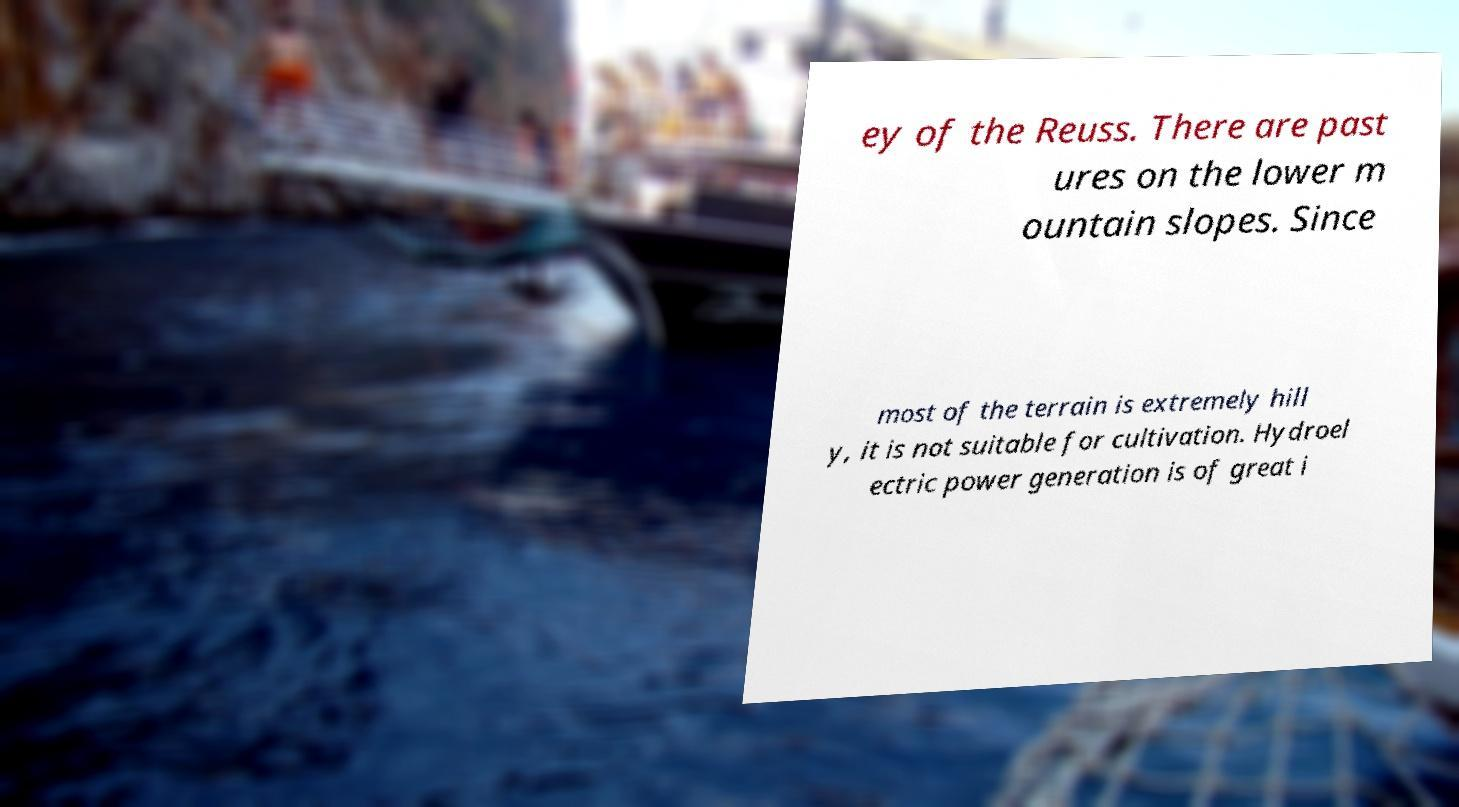Could you assist in decoding the text presented in this image and type it out clearly? ey of the Reuss. There are past ures on the lower m ountain slopes. Since most of the terrain is extremely hill y, it is not suitable for cultivation. Hydroel ectric power generation is of great i 